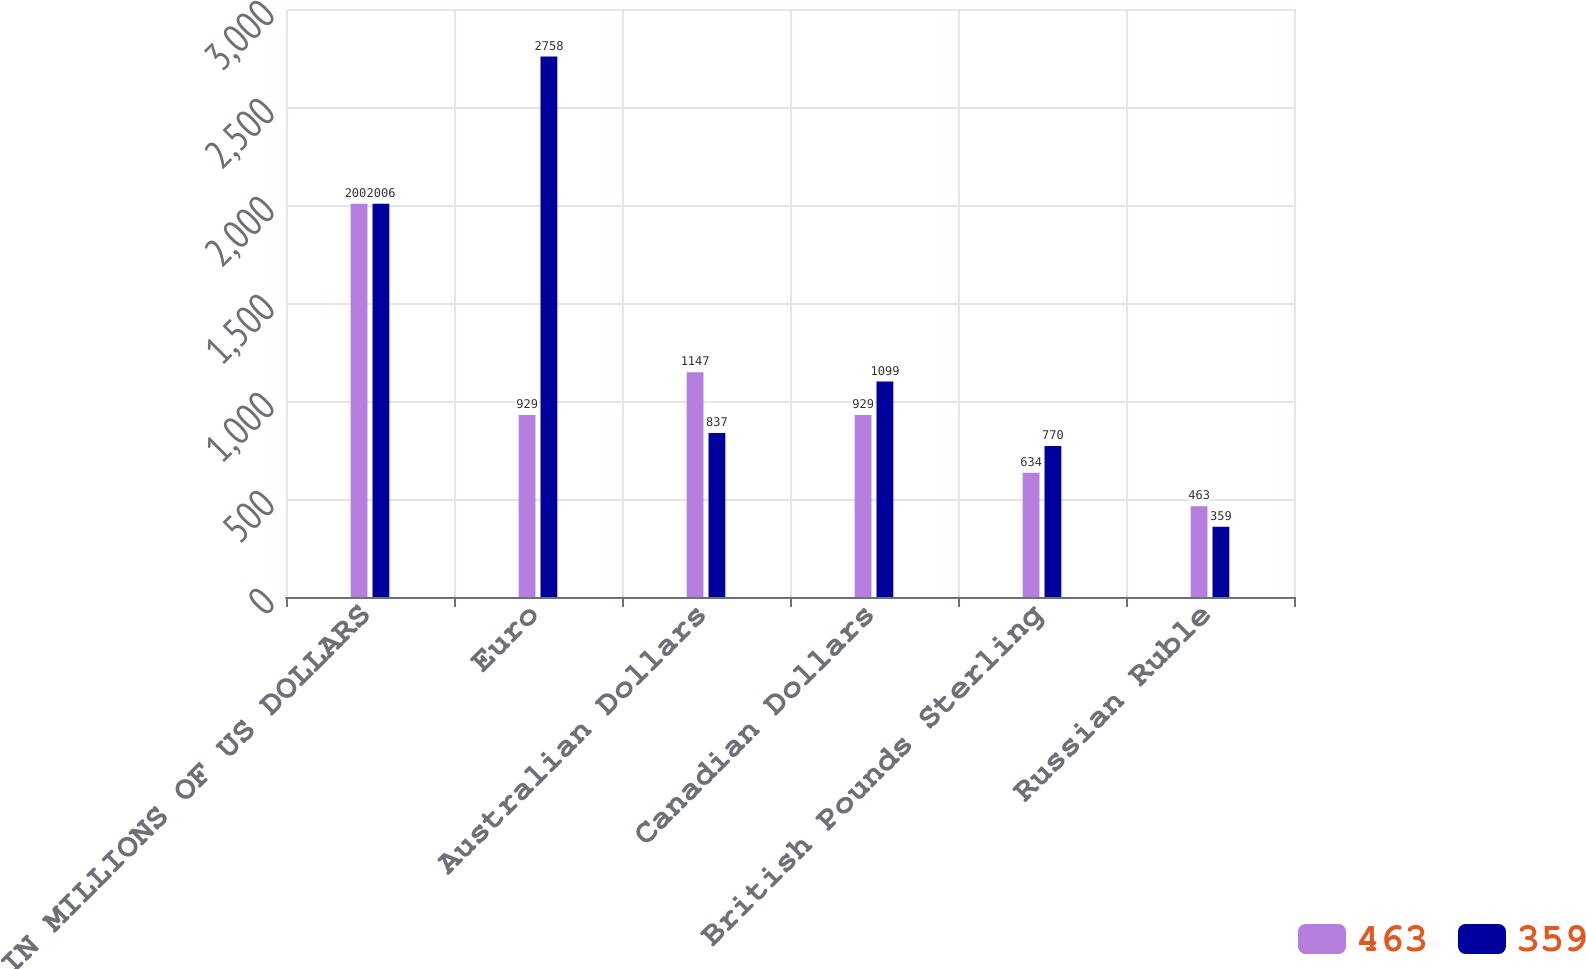Convert chart. <chart><loc_0><loc_0><loc_500><loc_500><stacked_bar_chart><ecel><fcel>IN MILLIONS OF US DOLLARS<fcel>Euro<fcel>Australian Dollars<fcel>Canadian Dollars<fcel>British Pounds Sterling<fcel>Russian Ruble<nl><fcel>463<fcel>2007<fcel>929<fcel>1147<fcel>929<fcel>634<fcel>463<nl><fcel>359<fcel>2006<fcel>2758<fcel>837<fcel>1099<fcel>770<fcel>359<nl></chart> 